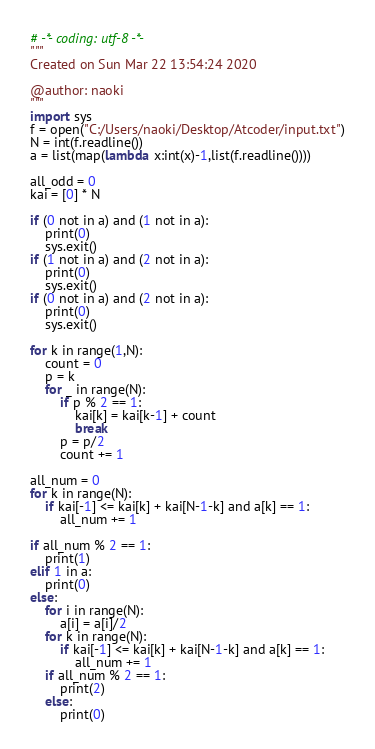<code> <loc_0><loc_0><loc_500><loc_500><_Python_># -*- coding: utf-8 -*-
"""
Created on Sun Mar 22 13:54:24 2020

@author: naoki
"""
import sys
f = open("C:/Users/naoki/Desktop/Atcoder/input.txt")
N = int(f.readline())
a = list(map(lambda x:int(x)-1,list(f.readline())))
   
all_odd = 0
kai = [0] * N

if (0 not in a) and (1 not in a):
    print(0)
    sys.exit()
if (1 not in a) and (2 not in a):
    print(0)
    sys.exit()
if (0 not in a) and (2 not in a):
    print(0)
    sys.exit()
    
for k in range(1,N):
    count = 0
    p = k
    for _ in range(N):
        if p % 2 == 1:
            kai[k] = kai[k-1] + count
            break
        p = p/2
        count += 1

all_num = 0
for k in range(N):
    if kai[-1] <= kai[k] + kai[N-1-k] and a[k] == 1:
        all_num += 1

if all_num % 2 == 1:
    print(1)
elif 1 in a:
    print(0)
else:
    for i in range(N):
        a[i] = a[i]/2
    for k in range(N):
        if kai[-1] <= kai[k] + kai[N-1-k] and a[k] == 1:
            all_num += 1
    if all_num % 2 == 1:
        print(2)
    else:
        print(0)</code> 